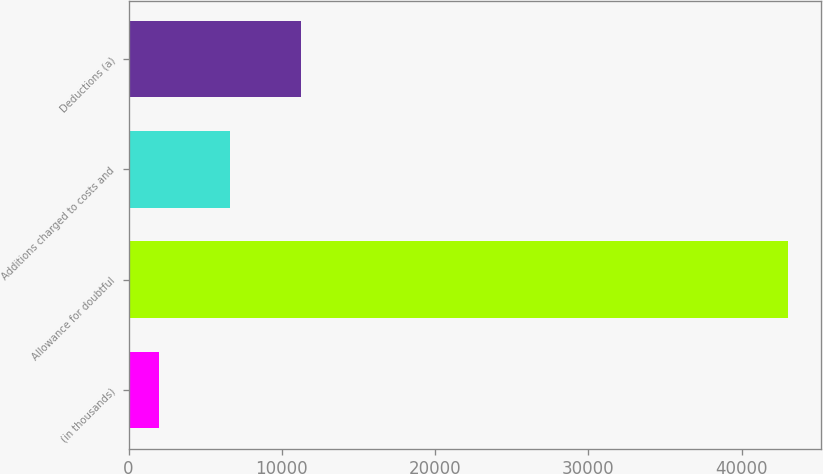<chart> <loc_0><loc_0><loc_500><loc_500><bar_chart><fcel>(in thousands)<fcel>Allowance for doubtful<fcel>Additions charged to costs and<fcel>Deductions (a)<nl><fcel>2016<fcel>43028<fcel>6626.3<fcel>11236.6<nl></chart> 